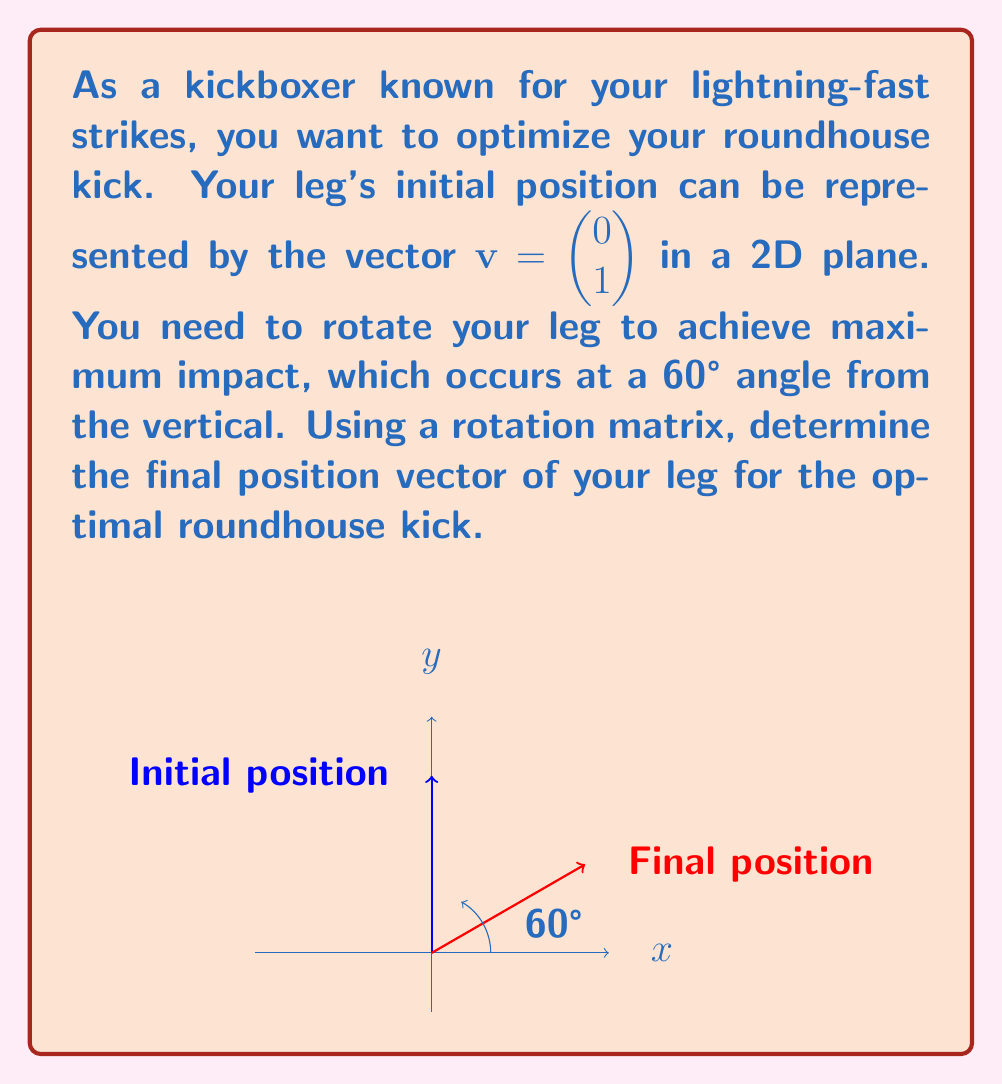Give your solution to this math problem. Let's approach this step-by-step:

1) The rotation matrix for a counterclockwise rotation by angle $\theta$ is:

   $$R(\theta) = \begin{pmatrix} \cos\theta & -\sin\theta \\ \sin\theta & \cos\theta \end{pmatrix}$$

2) We need to rotate by 60° counterclockwise from the vertical, which is equivalent to rotating 30° clockwise from the positive y-axis. So, we'll use $\theta = -30°$ or $-\frac{\pi}{6}$ radians.

3) Let's calculate the rotation matrix:

   $$R(-30°) = \begin{pmatrix} \cos(-30°) & -\sin(-30°) \\ \sin(-30°) & \cos(-30°) \end{pmatrix}$$

4) Using the values:
   $\cos(-30°) = \frac{\sqrt{3}}{2}$
   $\sin(-30°) = -\frac{1}{2}$

   We get:

   $$R(-30°) = \begin{pmatrix} \frac{\sqrt{3}}{2} & \frac{1}{2} \\ -\frac{1}{2} & \frac{\sqrt{3}}{2} \end{pmatrix}$$

5) Now, we multiply this matrix by our initial vector:

   $$\begin{pmatrix} \frac{\sqrt{3}}{2} & \frac{1}{2} \\ -\frac{1}{2} & \frac{\sqrt{3}}{2} \end{pmatrix} \begin{pmatrix} 0 \\ 1 \end{pmatrix}$$

6) Performing the matrix multiplication:

   $$\begin{pmatrix} \frac{\sqrt{3}}{2} \cdot 0 + \frac{1}{2} \cdot 1 \\ -\frac{1}{2} \cdot 0 + \frac{\sqrt{3}}{2} \cdot 1 \end{pmatrix} = \begin{pmatrix} \frac{1}{2} \\ \frac{\sqrt{3}}{2} \end{pmatrix}$$

This final vector represents the optimal position for your roundhouse kick.
Answer: $\begin{pmatrix} \frac{1}{2} \\ \frac{\sqrt{3}}{2} \end{pmatrix}$ 